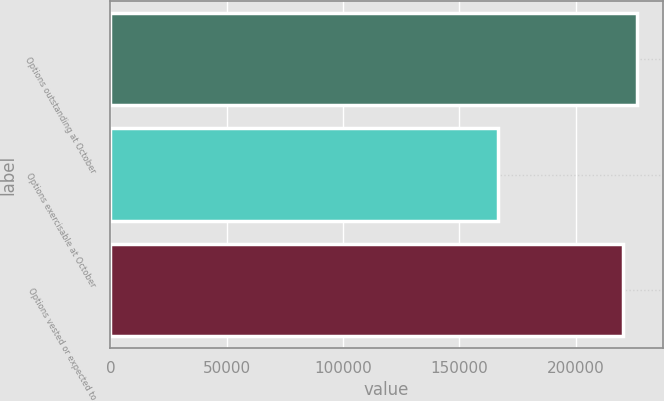Convert chart. <chart><loc_0><loc_0><loc_500><loc_500><bar_chart><fcel>Options outstanding at October<fcel>Options exercisable at October<fcel>Options vested or expected to<nl><fcel>226286<fcel>166673<fcel>220557<nl></chart> 